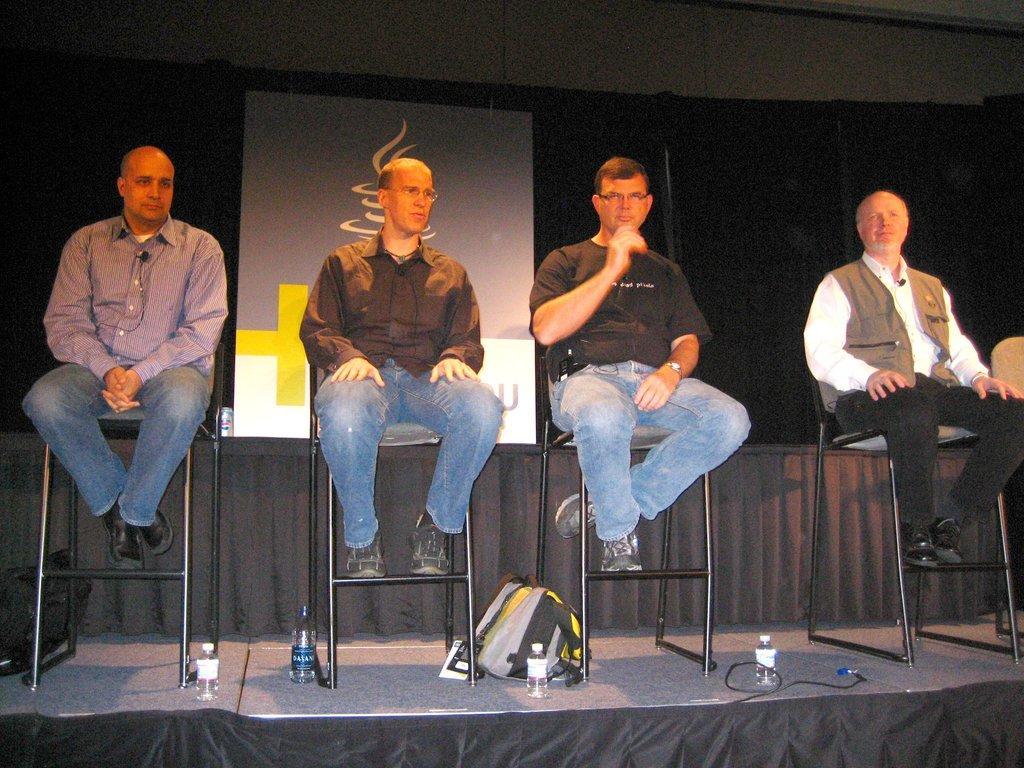How would you summarize this image in a sentence or two? In this picture we can see four people sitting on chairs on the stage, here we can see bottles and bags and in the background we can see a board. 